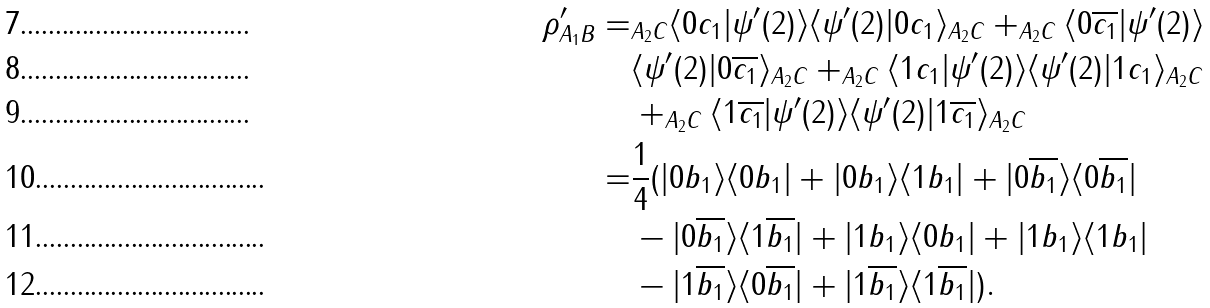Convert formula to latex. <formula><loc_0><loc_0><loc_500><loc_500>\rho ^ { \prime } _ { A _ { 1 } B } = & _ { A _ { 2 } C } \langle 0 c _ { 1 } | \psi ^ { \prime } ( 2 ) \rangle \langle \psi ^ { \prime } ( 2 ) | 0 c _ { 1 } \rangle _ { A _ { 2 } C } + _ { A _ { 2 } C } \langle 0 \overline { c _ { 1 } } | \psi ^ { \prime } ( 2 ) \rangle \\ & \langle \psi ^ { \prime } ( 2 ) | 0 \overline { c _ { 1 } } \rangle _ { A _ { 2 } C } + _ { A _ { 2 } C } \langle 1 c _ { 1 } | \psi ^ { \prime } ( 2 ) \rangle \langle \psi ^ { \prime } ( 2 ) | 1 c _ { 1 } \rangle _ { A _ { 2 } C } \\ & + _ { A _ { 2 } C } \langle 1 \overline { c _ { 1 } } | \psi ^ { \prime } ( 2 ) \rangle \langle \psi ^ { \prime } ( 2 ) | 1 \overline { c _ { 1 } } \rangle _ { A _ { 2 } C } \\ = & \frac { 1 } { 4 } ( | 0 b _ { 1 } \rangle \langle 0 b _ { 1 } | + | 0 b _ { 1 } \rangle \langle 1 b _ { 1 } | + | 0 \overline { b _ { 1 } } \rangle \langle 0 \overline { b _ { 1 } } | \\ & - | 0 \overline { b _ { 1 } } \rangle \langle 1 \overline { b _ { 1 } } | + | 1 b _ { 1 } \rangle \langle 0 b _ { 1 } | + | 1 b _ { 1 } \rangle \langle 1 b _ { 1 } | \\ & - | 1 \overline { b _ { 1 } } \rangle \langle 0 \overline { b _ { 1 } } | + | 1 \overline { b _ { 1 } } \rangle \langle 1 \overline { b _ { 1 } } | ) .</formula> 